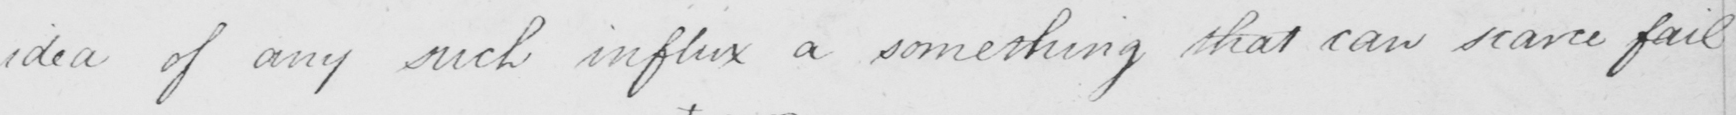Please transcribe the handwritten text in this image. idea of such influx of something that can scarce fail 